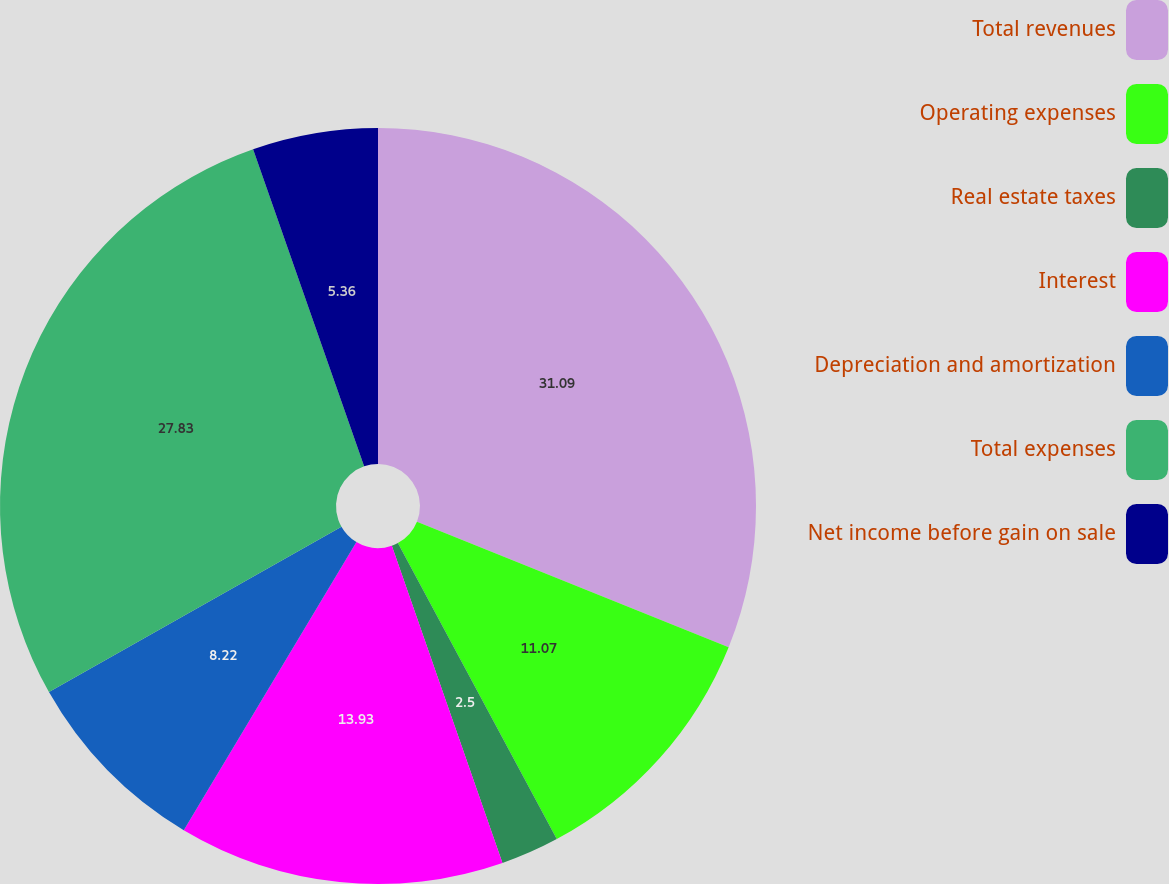<chart> <loc_0><loc_0><loc_500><loc_500><pie_chart><fcel>Total revenues<fcel>Operating expenses<fcel>Real estate taxes<fcel>Interest<fcel>Depreciation and amortization<fcel>Total expenses<fcel>Net income before gain on sale<nl><fcel>31.09%<fcel>11.07%<fcel>2.5%<fcel>13.93%<fcel>8.22%<fcel>27.83%<fcel>5.36%<nl></chart> 